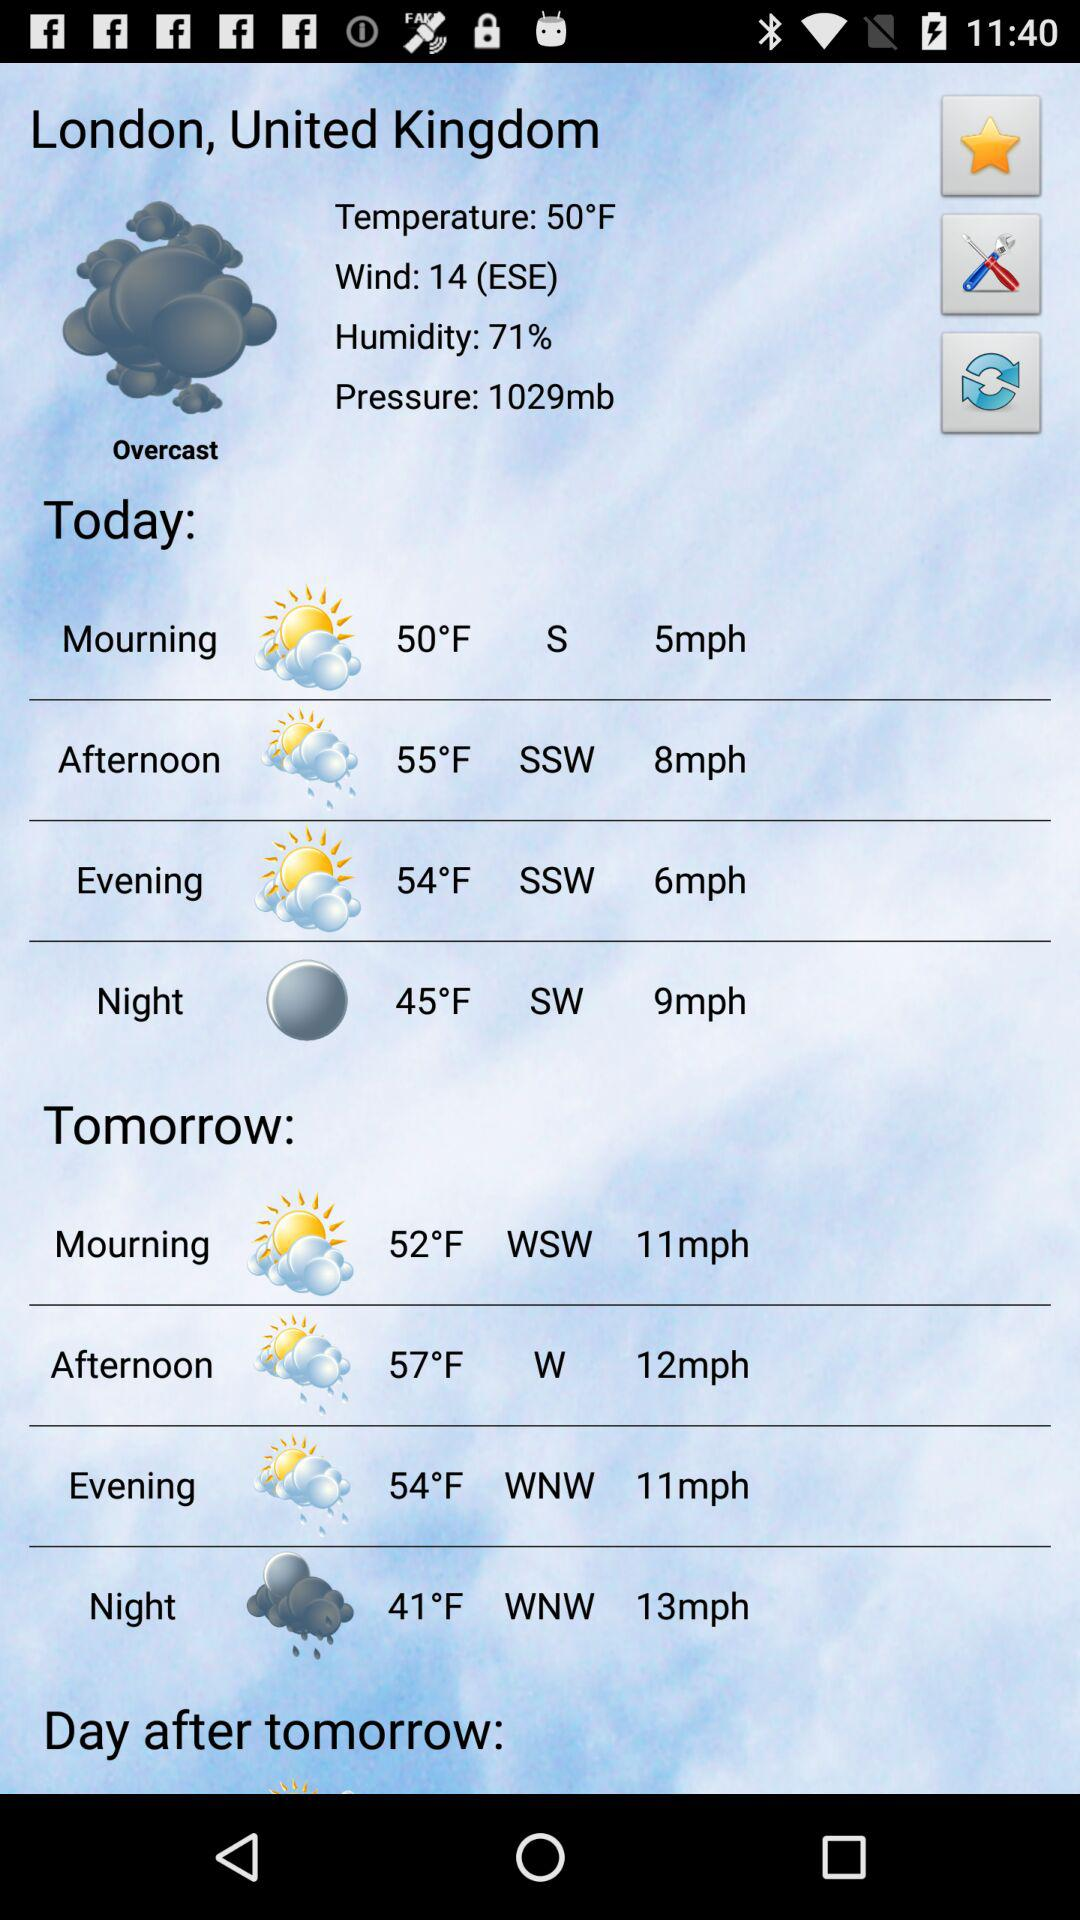What was the wind speed today at night in London? The wind speed in London today at night was 9 mph. 